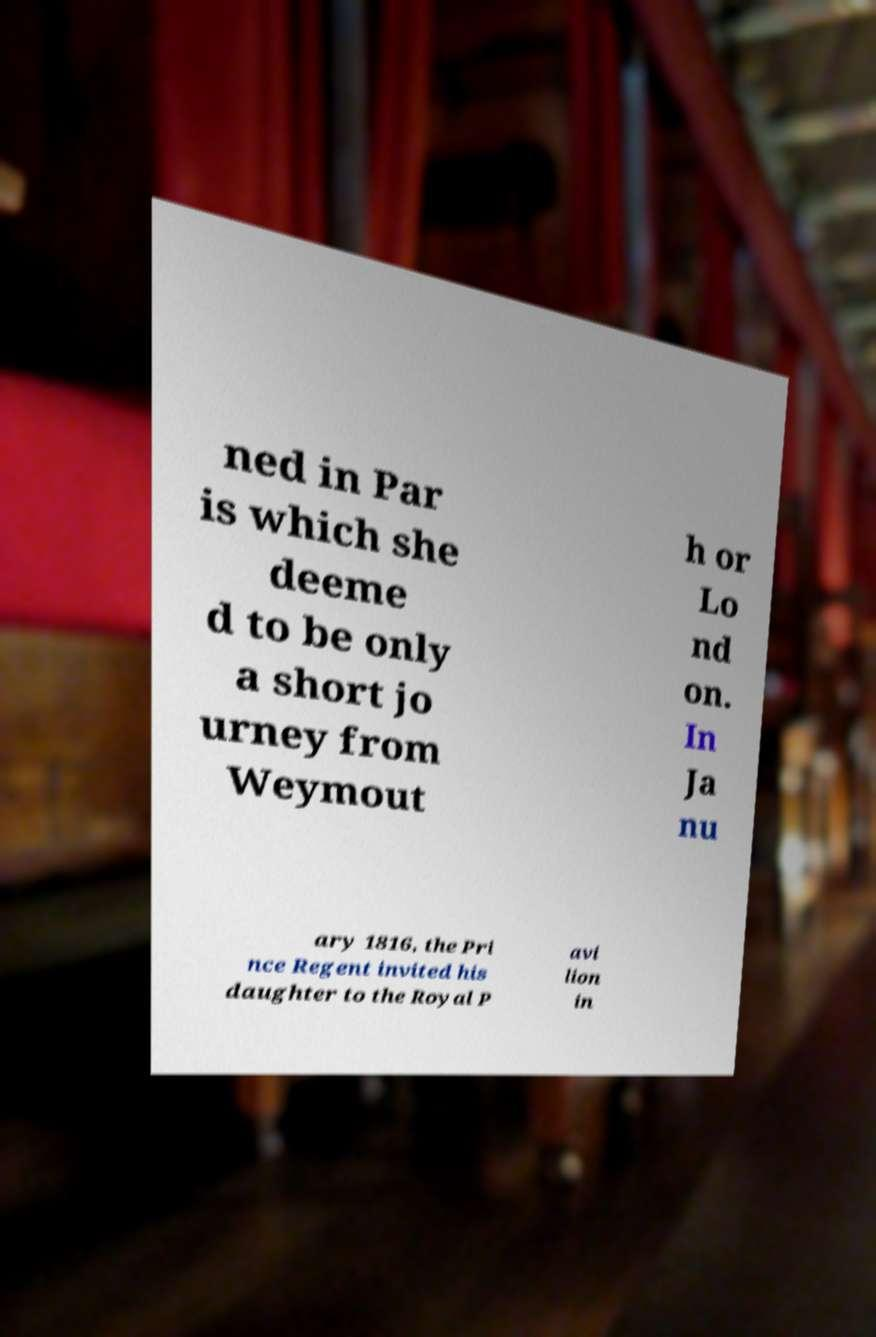I need the written content from this picture converted into text. Can you do that? ned in Par is which she deeme d to be only a short jo urney from Weymout h or Lo nd on. In Ja nu ary 1816, the Pri nce Regent invited his daughter to the Royal P avi lion in 